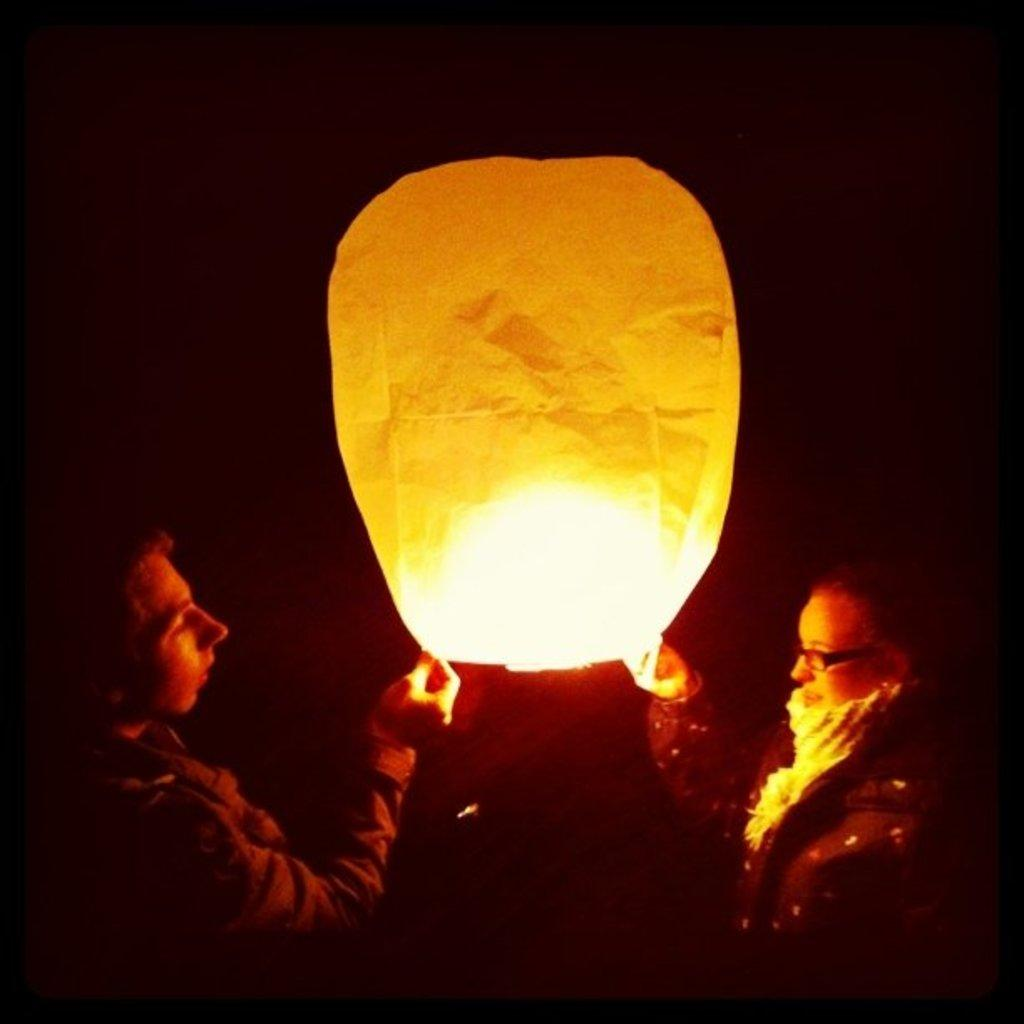What is the main subject of the image? There is a person standing in the image. What is the person holding in the image? The person is holding a lantern. Where is the lantern located in relation to the person? The lantern is in the center of the image. What type of creature is hiding in the drawer in the image? There is no drawer present in the image, and therefore no creature can be hiding in it. 